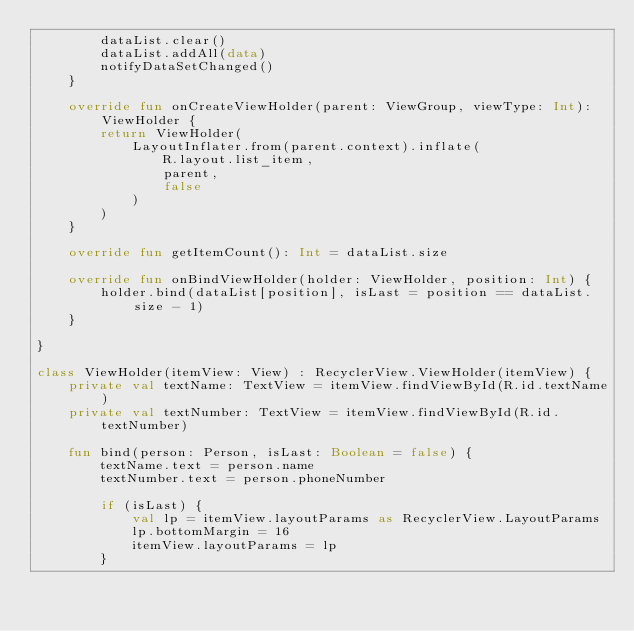<code> <loc_0><loc_0><loc_500><loc_500><_Kotlin_>        dataList.clear()
        dataList.addAll(data)
        notifyDataSetChanged()
    }

    override fun onCreateViewHolder(parent: ViewGroup, viewType: Int): ViewHolder {
        return ViewHolder(
            LayoutInflater.from(parent.context).inflate(
                R.layout.list_item,
                parent,
                false
            )
        )
    }

    override fun getItemCount(): Int = dataList.size

    override fun onBindViewHolder(holder: ViewHolder, position: Int) {
        holder.bind(dataList[position], isLast = position == dataList.size - 1)
    }

}

class ViewHolder(itemView: View) : RecyclerView.ViewHolder(itemView) {
    private val textName: TextView = itemView.findViewById(R.id.textName)
    private val textNumber: TextView = itemView.findViewById(R.id.textNumber)

    fun bind(person: Person, isLast: Boolean = false) {
        textName.text = person.name
        textNumber.text = person.phoneNumber

        if (isLast) {
            val lp = itemView.layoutParams as RecyclerView.LayoutParams
            lp.bottomMargin = 16
            itemView.layoutParams = lp
        }</code> 